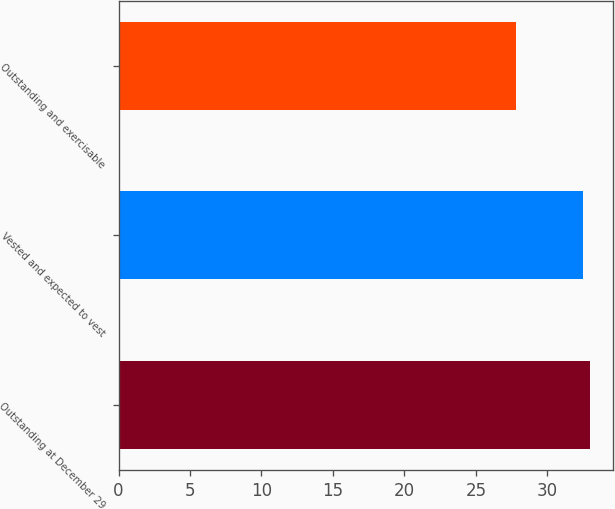<chart> <loc_0><loc_0><loc_500><loc_500><bar_chart><fcel>Outstanding at December 29<fcel>Vested and expected to vest<fcel>Outstanding and exercisable<nl><fcel>32.97<fcel>32.48<fcel>27.78<nl></chart> 